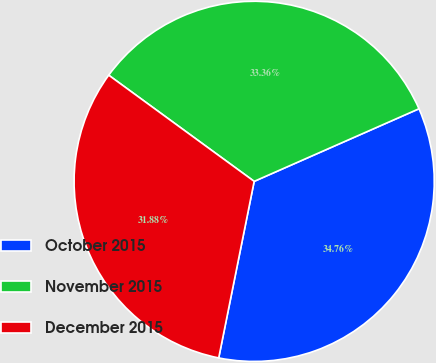Convert chart. <chart><loc_0><loc_0><loc_500><loc_500><pie_chart><fcel>October 2015<fcel>November 2015<fcel>December 2015<nl><fcel>34.76%<fcel>33.36%<fcel>31.88%<nl></chart> 